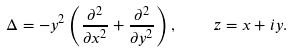<formula> <loc_0><loc_0><loc_500><loc_500>\Delta = - y ^ { 2 } \left ( \frac { \partial ^ { 2 } } { \partial x ^ { 2 } } + \frac { \partial ^ { 2 } } { \partial y ^ { 2 } } \right ) , \quad z = x + i y .</formula> 